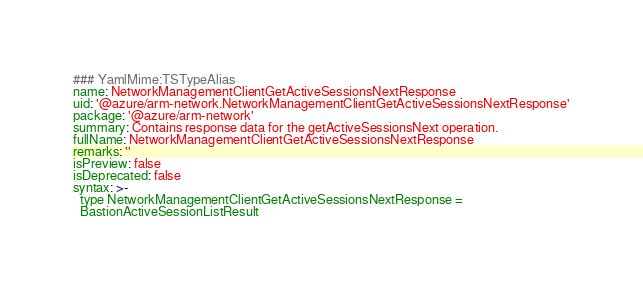<code> <loc_0><loc_0><loc_500><loc_500><_YAML_>### YamlMime:TSTypeAlias
name: NetworkManagementClientGetActiveSessionsNextResponse
uid: '@azure/arm-network.NetworkManagementClientGetActiveSessionsNextResponse'
package: '@azure/arm-network'
summary: Contains response data for the getActiveSessionsNext operation.
fullName: NetworkManagementClientGetActiveSessionsNextResponse
remarks: ''
isPreview: false
isDeprecated: false
syntax: >-
  type NetworkManagementClientGetActiveSessionsNextResponse =
  BastionActiveSessionListResult
</code> 